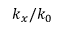Convert formula to latex. <formula><loc_0><loc_0><loc_500><loc_500>k _ { x } / k _ { 0 }</formula> 